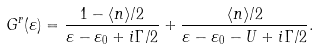<formula> <loc_0><loc_0><loc_500><loc_500>G ^ { r } ( \varepsilon ) = \frac { 1 - \langle n \rangle / 2 } { \varepsilon - \varepsilon _ { 0 } + i \Gamma / 2 } + \frac { \langle n \rangle / 2 } { \varepsilon - \varepsilon _ { 0 } - U + i \Gamma / 2 } .</formula> 